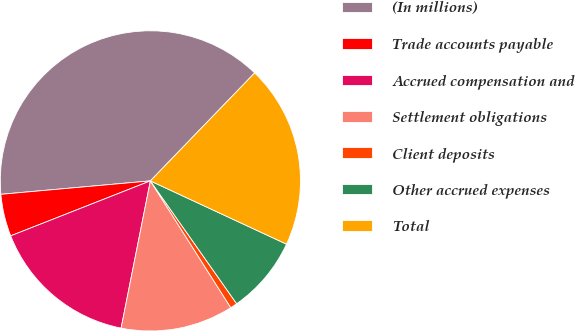<chart> <loc_0><loc_0><loc_500><loc_500><pie_chart><fcel>(In millions)<fcel>Trade accounts payable<fcel>Accrued compensation and<fcel>Settlement obligations<fcel>Client deposits<fcel>Other accrued expenses<fcel>Total<nl><fcel>38.65%<fcel>4.54%<fcel>15.91%<fcel>12.12%<fcel>0.75%<fcel>8.33%<fcel>19.7%<nl></chart> 